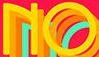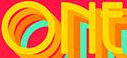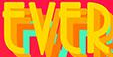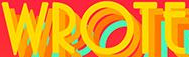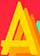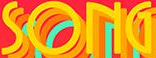Transcribe the words shown in these images in order, separated by a semicolon. NO; ONE; EVER; WROTE; A; SONG 